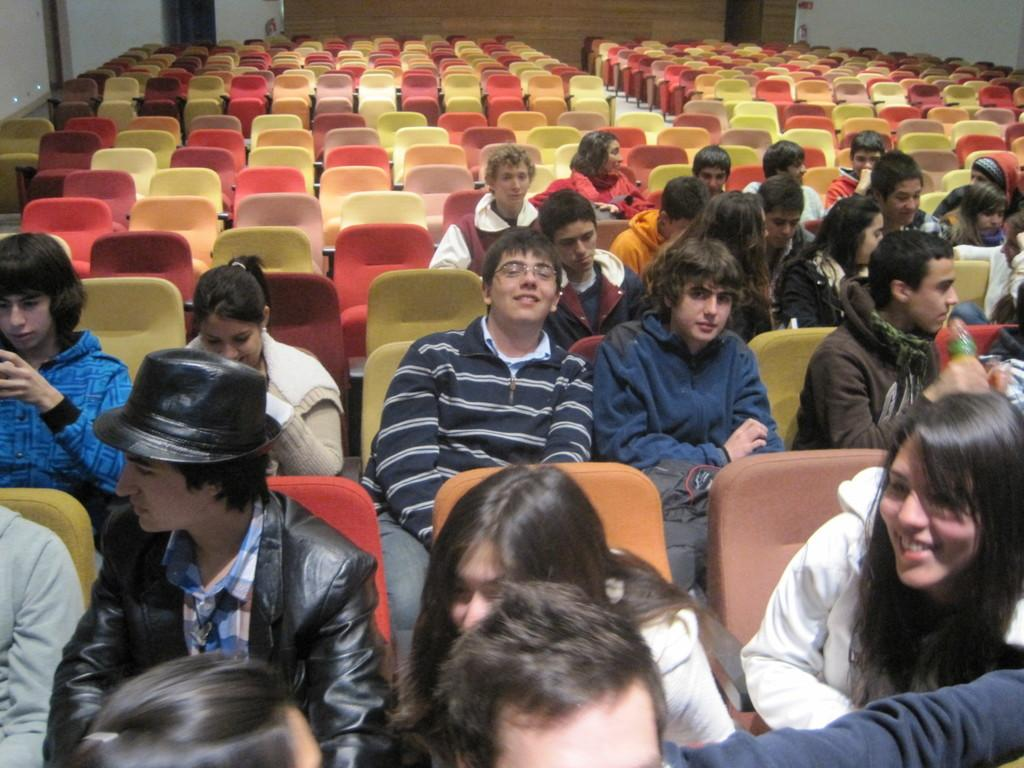What are the people in the image doing? The people in the image are sitting in chairs. What can be seen in the background of the image? There is a wall in the background of the image. Are there any other chairs visible in the image? Yes, there are additional chairs visible in the background of the image. What type of lettuce is being used as a tablecloth in the image? There is no lettuce present in the image, and it is not being used as a tablecloth. 